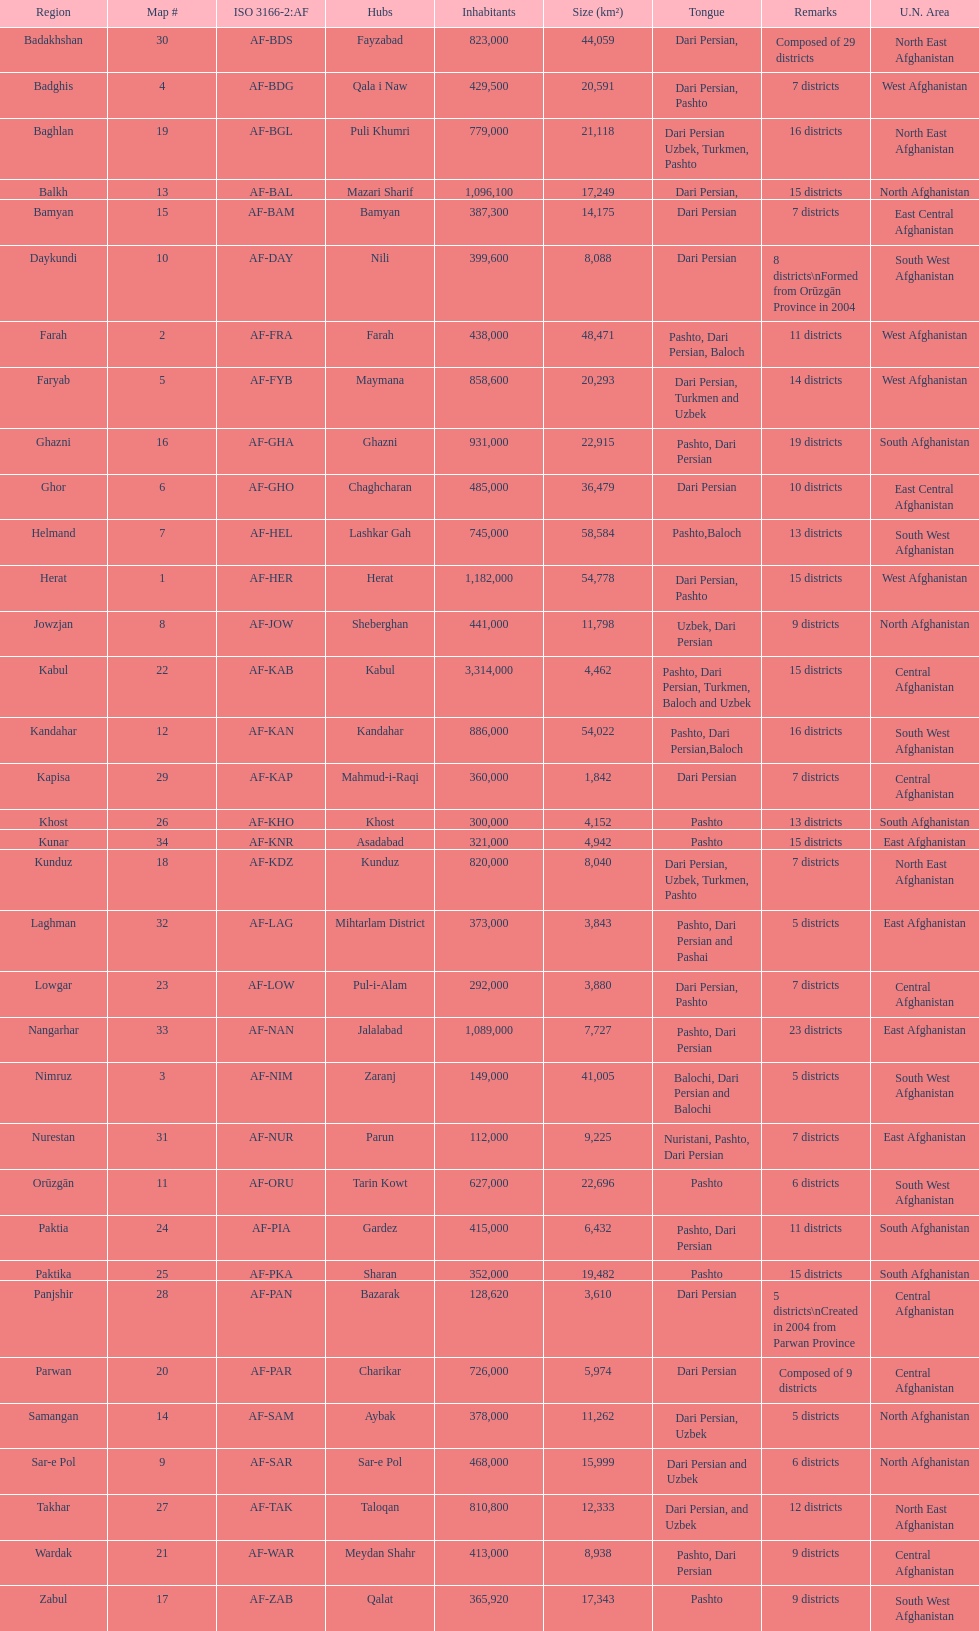Give the province with the least population Nurestan. 